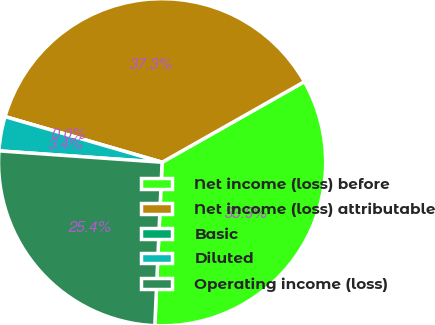Convert chart. <chart><loc_0><loc_0><loc_500><loc_500><pie_chart><fcel>Net income (loss) before<fcel>Net income (loss) attributable<fcel>Basic<fcel>Diluted<fcel>Operating income (loss)<nl><fcel>33.91%<fcel>37.3%<fcel>0.0%<fcel>3.39%<fcel>25.4%<nl></chart> 